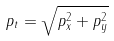Convert formula to latex. <formula><loc_0><loc_0><loc_500><loc_500>p _ { t } = \sqrt { p _ { x } ^ { 2 } + p _ { y } ^ { 2 } }</formula> 